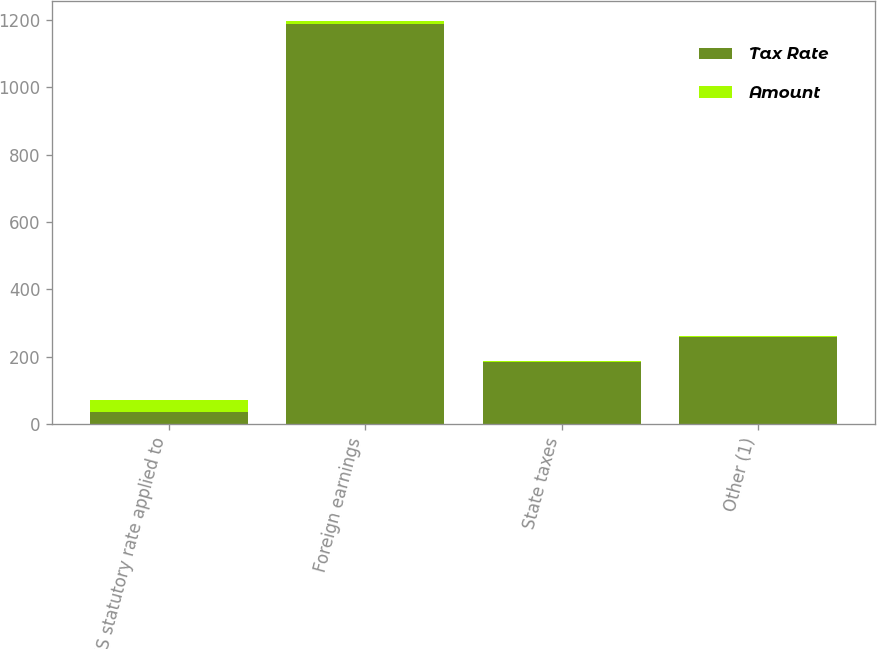<chart> <loc_0><loc_0><loc_500><loc_500><stacked_bar_chart><ecel><fcel>US statutory rate applied to<fcel>Foreign earnings<fcel>State taxes<fcel>Other (1)<nl><fcel>Tax Rate<fcel>35<fcel>1189<fcel>185.1<fcel>259<nl><fcel>Amount<fcel>35<fcel>7.8<fcel>1.2<fcel>1.7<nl></chart> 